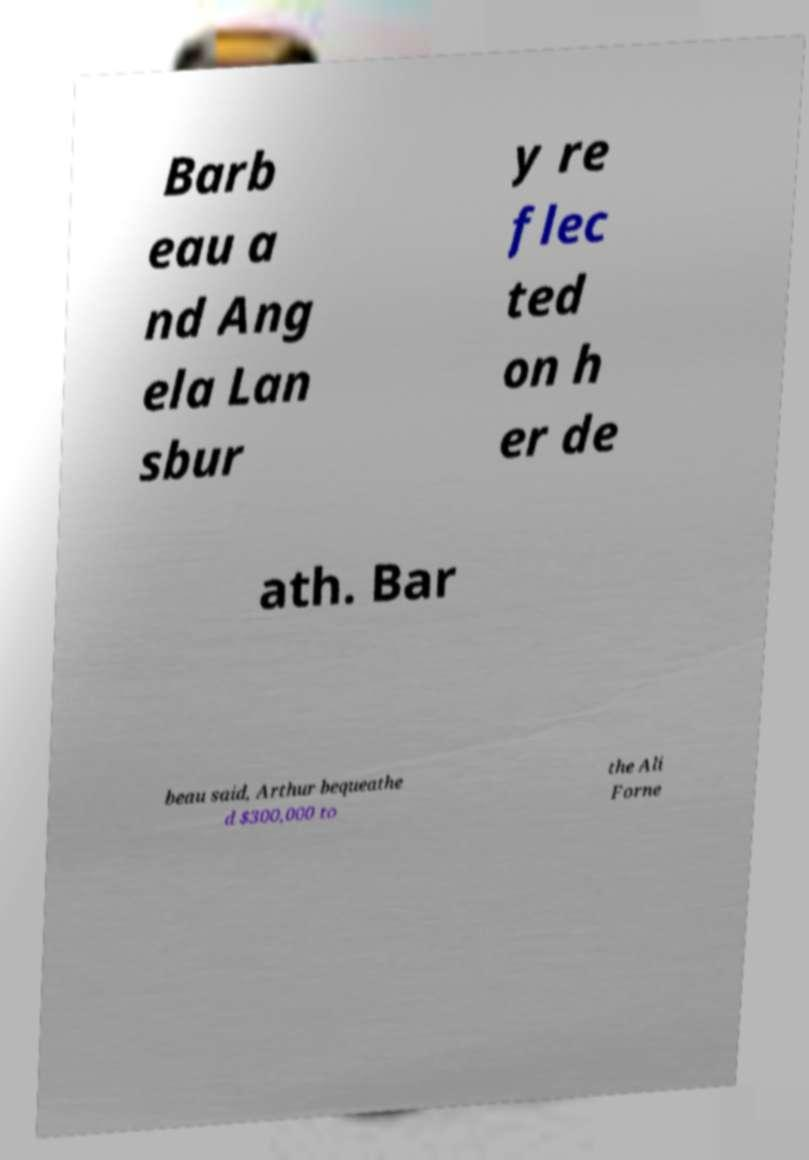Please identify and transcribe the text found in this image. Barb eau a nd Ang ela Lan sbur y re flec ted on h er de ath. Bar beau said, Arthur bequeathe d $300,000 to the Ali Forne 